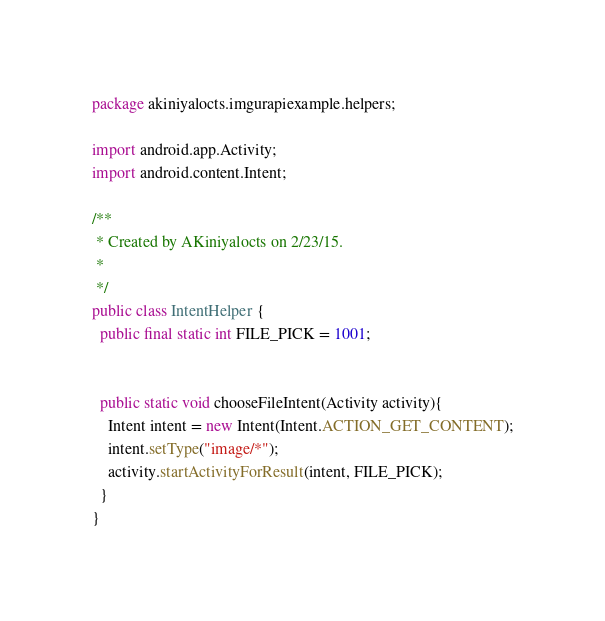<code> <loc_0><loc_0><loc_500><loc_500><_Java_>package akiniyalocts.imgurapiexample.helpers;

import android.app.Activity;
import android.content.Intent;

/**
 * Created by AKiniyalocts on 2/23/15.
 *
 */
public class IntentHelper {
  public final static int FILE_PICK = 1001;


  public static void chooseFileIntent(Activity activity){
    Intent intent = new Intent(Intent.ACTION_GET_CONTENT);
    intent.setType("image/*");
    activity.startActivityForResult(intent, FILE_PICK);
  }
}
</code> 